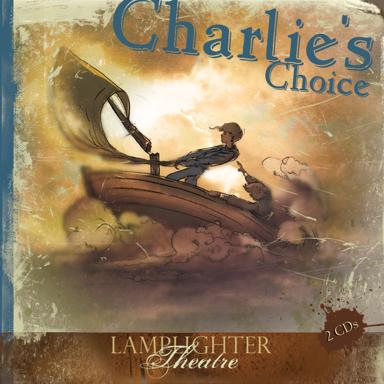Can you describe the visual elements used on the cover of 'Charlie's Choice'? The cover art of 'Charlie's Choice' uses vibrant and dynamic elements. It features a boy on a stylized boat, navigating through fantastical, swirling clouds that resemble waves, which adds a surreal, dreamy ambience to the scene. The soft, warm color palette emphasizes the feel of a journey set during either sunrise or sunset. How does this artwork influence the perception of the story? The artistic choices on the cover convey a sense of mystery and wonder, potentially drawing the viewer into the protagonist's journey. This imaginative portrayal may lead readers to anticipate a story full of exploration, personal growth, and overcoming obstacles through resilience and courage. 